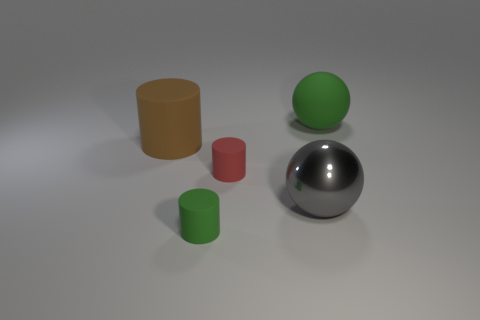Do the red thing and the green cylinder have the same size?
Offer a terse response. Yes. Are there any large shiny objects?
Make the answer very short. Yes. Are there any large objects that have the same material as the small red cylinder?
Provide a short and direct response. Yes. Is there anything else that is the same material as the gray object?
Offer a very short reply. No. What is the color of the metal ball?
Keep it short and to the point. Gray. There is a object that is the same color as the large matte sphere; what is its shape?
Give a very brief answer. Cylinder. What is the color of the cylinder that is the same size as the shiny ball?
Your response must be concise. Brown. How many rubber things are big gray balls or tiny yellow objects?
Your response must be concise. 0. How many matte things are left of the big green ball and to the right of the big brown object?
Your answer should be compact. 2. Are there any other things that are the same shape as the gray object?
Your answer should be compact. Yes. 